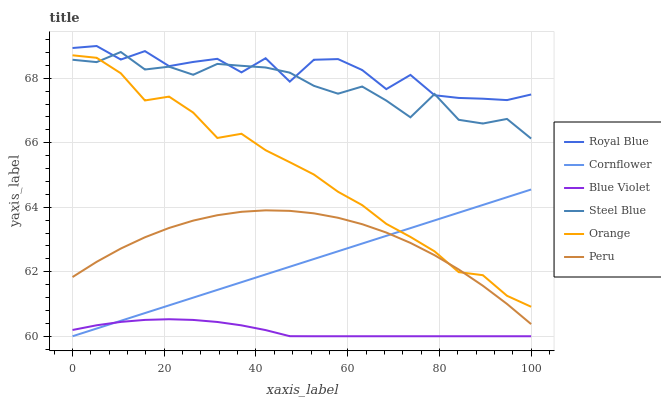Does Blue Violet have the minimum area under the curve?
Answer yes or no. Yes. Does Royal Blue have the maximum area under the curve?
Answer yes or no. Yes. Does Steel Blue have the minimum area under the curve?
Answer yes or no. No. Does Steel Blue have the maximum area under the curve?
Answer yes or no. No. Is Cornflower the smoothest?
Answer yes or no. Yes. Is Royal Blue the roughest?
Answer yes or no. Yes. Is Steel Blue the smoothest?
Answer yes or no. No. Is Steel Blue the roughest?
Answer yes or no. No. Does Steel Blue have the lowest value?
Answer yes or no. No. Does Steel Blue have the highest value?
Answer yes or no. No. Is Peru less than Royal Blue?
Answer yes or no. Yes. Is Steel Blue greater than Blue Violet?
Answer yes or no. Yes. Does Peru intersect Royal Blue?
Answer yes or no. No. 